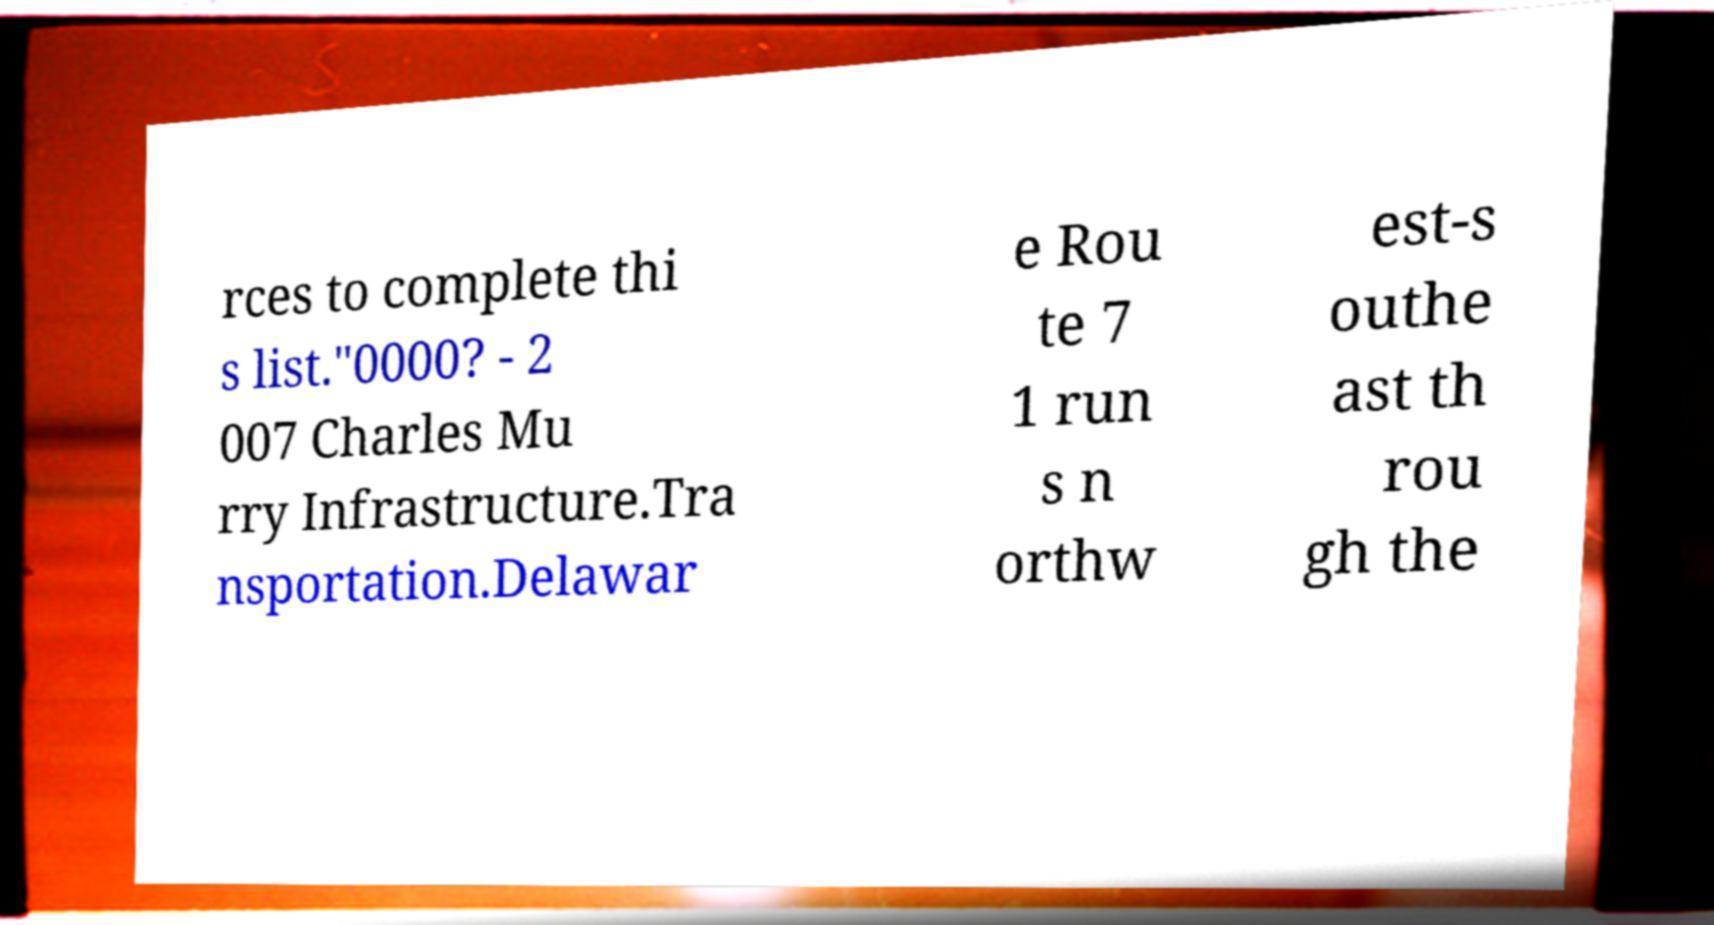Please read and relay the text visible in this image. What does it say? rces to complete thi s list."0000? - 2 007 Charles Mu rry Infrastructure.Tra nsportation.Delawar e Rou te 7 1 run s n orthw est-s outhe ast th rou gh the 